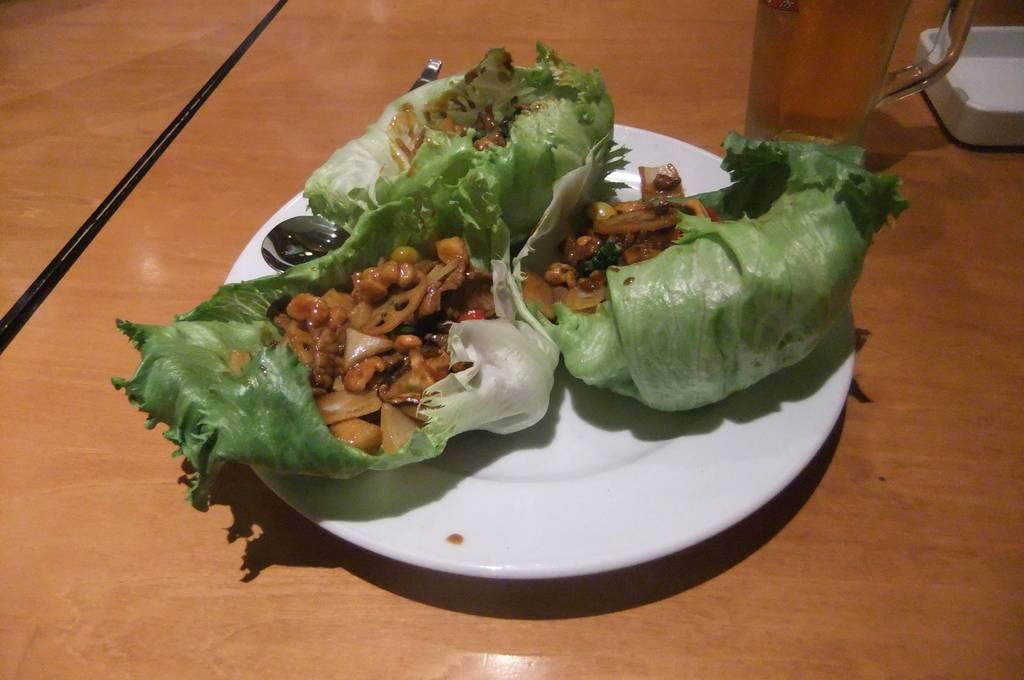What is present in the image that people typically eat? There is food in the image. What utensil is in the plate with the food? There is a spoon in the plate. What can be seen on the table besides the plate with food? There is a glass on the table. What object on the table might be used for holding small items? There is an object that looks like an ashtray on the table. How many legs can be seen on the bomb in the image? There is no bomb present in the image, so it is not possible to determine the number of legs on a bomb. 